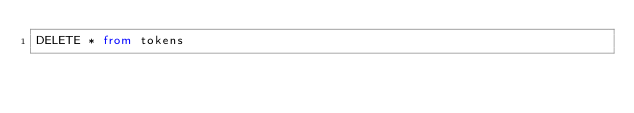<code> <loc_0><loc_0><loc_500><loc_500><_SQL_>DELETE * from tokens</code> 